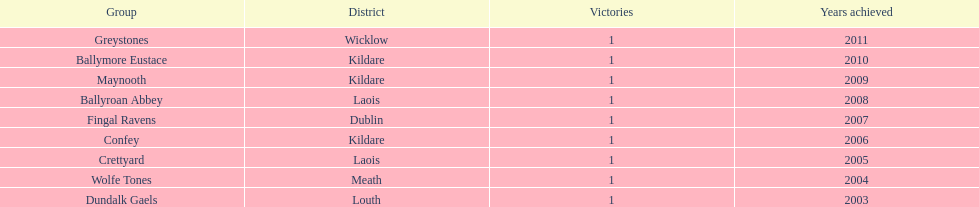Could you parse the entire table as a dict? {'header': ['Group', 'District', 'Victories', 'Years achieved'], 'rows': [['Greystones', 'Wicklow', '1', '2011'], ['Ballymore Eustace', 'Kildare', '1', '2010'], ['Maynooth', 'Kildare', '1', '2009'], ['Ballyroan Abbey', 'Laois', '1', '2008'], ['Fingal Ravens', 'Dublin', '1', '2007'], ['Confey', 'Kildare', '1', '2006'], ['Crettyard', 'Laois', '1', '2005'], ['Wolfe Tones', 'Meath', '1', '2004'], ['Dundalk Gaels', 'Louth', '1', '2003']]} What is the last team on the chart Dundalk Gaels. 